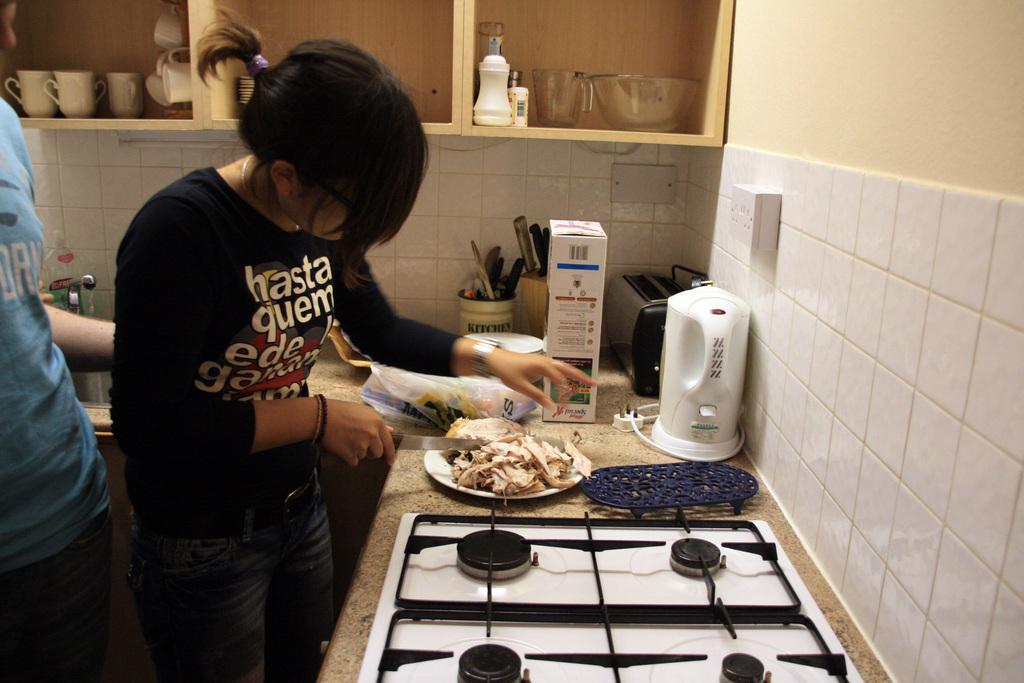What room is this according to the woman's utensil container?
Your answer should be compact. Kitchen. 